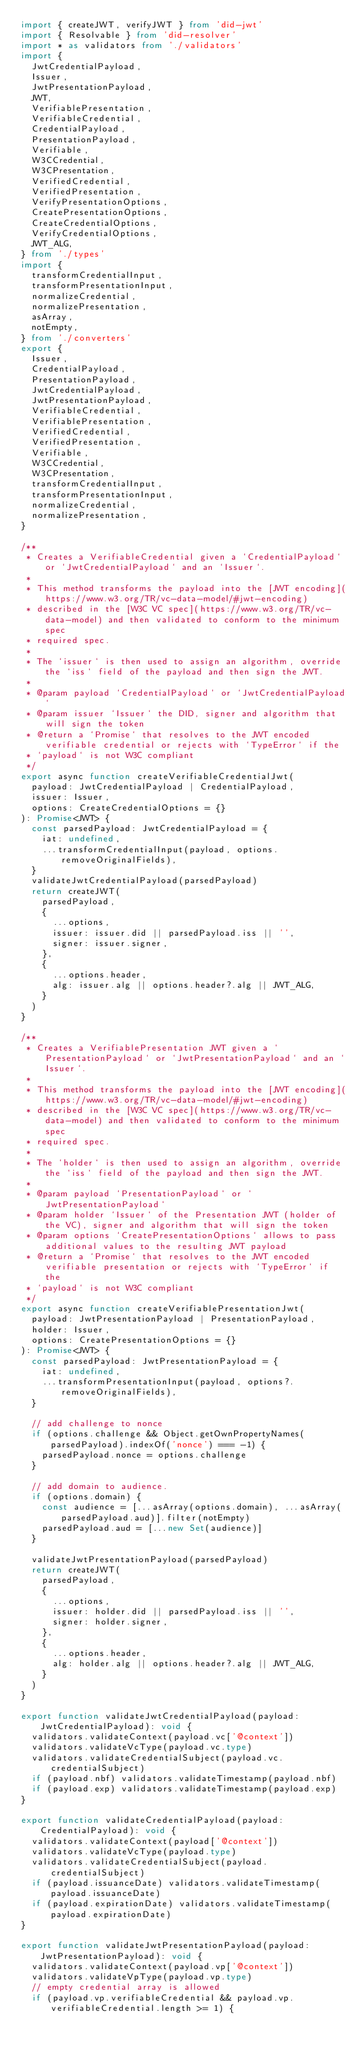<code> <loc_0><loc_0><loc_500><loc_500><_TypeScript_>import { createJWT, verifyJWT } from 'did-jwt'
import { Resolvable } from 'did-resolver'
import * as validators from './validators'
import {
  JwtCredentialPayload,
  Issuer,
  JwtPresentationPayload,
  JWT,
  VerifiablePresentation,
  VerifiableCredential,
  CredentialPayload,
  PresentationPayload,
  Verifiable,
  W3CCredential,
  W3CPresentation,
  VerifiedCredential,
  VerifiedPresentation,
  VerifyPresentationOptions,
  CreatePresentationOptions,
  CreateCredentialOptions,
  VerifyCredentialOptions,
  JWT_ALG,
} from './types'
import {
  transformCredentialInput,
  transformPresentationInput,
  normalizeCredential,
  normalizePresentation,
  asArray,
  notEmpty,
} from './converters'
export {
  Issuer,
  CredentialPayload,
  PresentationPayload,
  JwtCredentialPayload,
  JwtPresentationPayload,
  VerifiableCredential,
  VerifiablePresentation,
  VerifiedCredential,
  VerifiedPresentation,
  Verifiable,
  W3CCredential,
  W3CPresentation,
  transformCredentialInput,
  transformPresentationInput,
  normalizeCredential,
  normalizePresentation,
}

/**
 * Creates a VerifiableCredential given a `CredentialPayload` or `JwtCredentialPayload` and an `Issuer`.
 *
 * This method transforms the payload into the [JWT encoding](https://www.w3.org/TR/vc-data-model/#jwt-encoding)
 * described in the [W3C VC spec](https://www.w3.org/TR/vc-data-model) and then validated to conform to the minimum spec
 * required spec.
 *
 * The `issuer` is then used to assign an algorithm, override the `iss` field of the payload and then sign the JWT.
 *
 * @param payload `CredentialPayload` or `JwtCredentialPayload`
 * @param issuer `Issuer` the DID, signer and algorithm that will sign the token
 * @return a `Promise` that resolves to the JWT encoded verifiable credential or rejects with `TypeError` if the
 * `payload` is not W3C compliant
 */
export async function createVerifiableCredentialJwt(
  payload: JwtCredentialPayload | CredentialPayload,
  issuer: Issuer,
  options: CreateCredentialOptions = {}
): Promise<JWT> {
  const parsedPayload: JwtCredentialPayload = {
    iat: undefined,
    ...transformCredentialInput(payload, options.removeOriginalFields),
  }
  validateJwtCredentialPayload(parsedPayload)
  return createJWT(
    parsedPayload,
    {
      ...options,
      issuer: issuer.did || parsedPayload.iss || '',
      signer: issuer.signer,
    },
    {
      ...options.header,
      alg: issuer.alg || options.header?.alg || JWT_ALG,
    }
  )
}

/**
 * Creates a VerifiablePresentation JWT given a `PresentationPayload` or `JwtPresentationPayload` and an `Issuer`.
 *
 * This method transforms the payload into the [JWT encoding](https://www.w3.org/TR/vc-data-model/#jwt-encoding)
 * described in the [W3C VC spec](https://www.w3.org/TR/vc-data-model) and then validated to conform to the minimum spec
 * required spec.
 *
 * The `holder` is then used to assign an algorithm, override the `iss` field of the payload and then sign the JWT.
 *
 * @param payload `PresentationPayload` or `JwtPresentationPayload`
 * @param holder `Issuer` of the Presentation JWT (holder of the VC), signer and algorithm that will sign the token
 * @param options `CreatePresentationOptions` allows to pass additional values to the resulting JWT payload
 * @return a `Promise` that resolves to the JWT encoded verifiable presentation or rejects with `TypeError` if the
 * `payload` is not W3C compliant
 */
export async function createVerifiablePresentationJwt(
  payload: JwtPresentationPayload | PresentationPayload,
  holder: Issuer,
  options: CreatePresentationOptions = {}
): Promise<JWT> {
  const parsedPayload: JwtPresentationPayload = {
    iat: undefined,
    ...transformPresentationInput(payload, options?.removeOriginalFields),
  }

  // add challenge to nonce
  if (options.challenge && Object.getOwnPropertyNames(parsedPayload).indexOf('nonce') === -1) {
    parsedPayload.nonce = options.challenge
  }

  // add domain to audience.
  if (options.domain) {
    const audience = [...asArray(options.domain), ...asArray(parsedPayload.aud)].filter(notEmpty)
    parsedPayload.aud = [...new Set(audience)]
  }

  validateJwtPresentationPayload(parsedPayload)
  return createJWT(
    parsedPayload,
    {
      ...options,
      issuer: holder.did || parsedPayload.iss || '',
      signer: holder.signer,
    },
    {
      ...options.header,
      alg: holder.alg || options.header?.alg || JWT_ALG,
    }
  )
}

export function validateJwtCredentialPayload(payload: JwtCredentialPayload): void {
  validators.validateContext(payload.vc['@context'])
  validators.validateVcType(payload.vc.type)
  validators.validateCredentialSubject(payload.vc.credentialSubject)
  if (payload.nbf) validators.validateTimestamp(payload.nbf)
  if (payload.exp) validators.validateTimestamp(payload.exp)
}

export function validateCredentialPayload(payload: CredentialPayload): void {
  validators.validateContext(payload['@context'])
  validators.validateVcType(payload.type)
  validators.validateCredentialSubject(payload.credentialSubject)
  if (payload.issuanceDate) validators.validateTimestamp(payload.issuanceDate)
  if (payload.expirationDate) validators.validateTimestamp(payload.expirationDate)
}

export function validateJwtPresentationPayload(payload: JwtPresentationPayload): void {
  validators.validateContext(payload.vp['@context'])
  validators.validateVpType(payload.vp.type)
  // empty credential array is allowed
  if (payload.vp.verifiableCredential && payload.vp.verifiableCredential.length >= 1) {</code> 